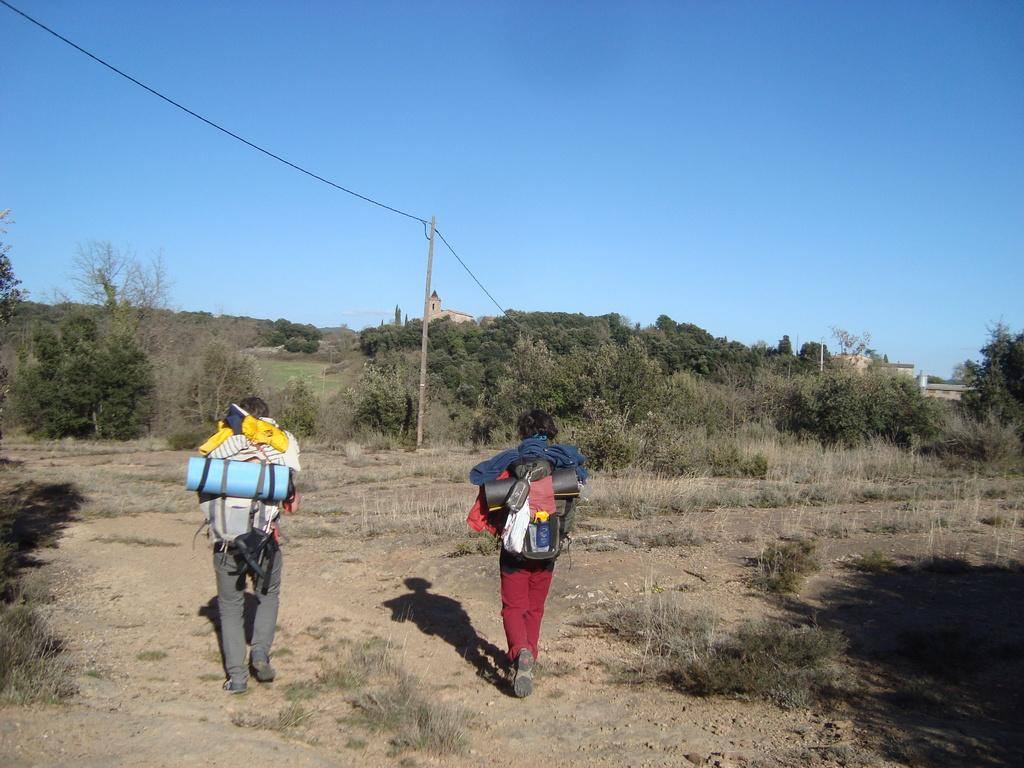How many people are in the image? There are two people in the image. What are the people doing in the image? The people are walking on the ground and carrying their luggage. What can be seen in the background of the image? There is a group of trees, houses, grass, a pole with wires, and the sky visible in the background. What type of flame can be seen coming from the maid's hair in the image? There is no maid or flame present in the image. 